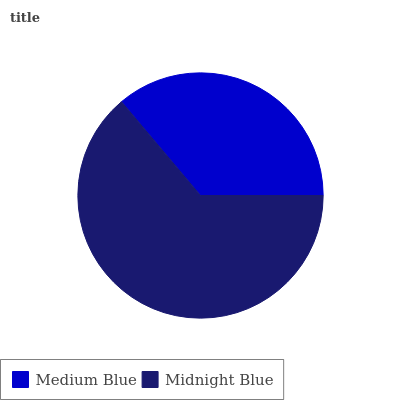Is Medium Blue the minimum?
Answer yes or no. Yes. Is Midnight Blue the maximum?
Answer yes or no. Yes. Is Midnight Blue the minimum?
Answer yes or no. No. Is Midnight Blue greater than Medium Blue?
Answer yes or no. Yes. Is Medium Blue less than Midnight Blue?
Answer yes or no. Yes. Is Medium Blue greater than Midnight Blue?
Answer yes or no. No. Is Midnight Blue less than Medium Blue?
Answer yes or no. No. Is Midnight Blue the high median?
Answer yes or no. Yes. Is Medium Blue the low median?
Answer yes or no. Yes. Is Medium Blue the high median?
Answer yes or no. No. Is Midnight Blue the low median?
Answer yes or no. No. 